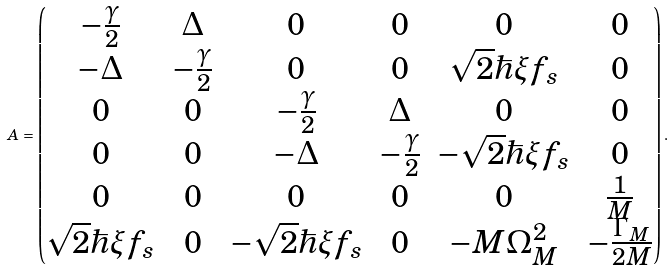Convert formula to latex. <formula><loc_0><loc_0><loc_500><loc_500>A = \begin{pmatrix} - \frac { \gamma } { 2 } & \Delta & 0 & 0 & 0 & 0 \\ - \Delta & - \frac { \gamma } { 2 } & 0 & 0 & \sqrt { 2 } \hbar { \xi } f _ { s } & 0 \\ 0 & 0 & - \frac { \gamma } { 2 } & \Delta & 0 & 0 \\ 0 & 0 & - \Delta & - \frac { \gamma } { 2 } & - \sqrt { 2 } \hbar { \xi } f _ { s } & 0 \\ 0 & 0 & 0 & 0 & 0 & \frac { 1 } { M } \\ \sqrt { 2 } \hbar { \xi } f _ { s } & 0 & - \sqrt { 2 } \hbar { \xi } f _ { s } & 0 & - M \Omega _ { M } ^ { 2 } & - \frac { \Gamma _ { M } } { 2 M } \\ \end{pmatrix} .</formula> 